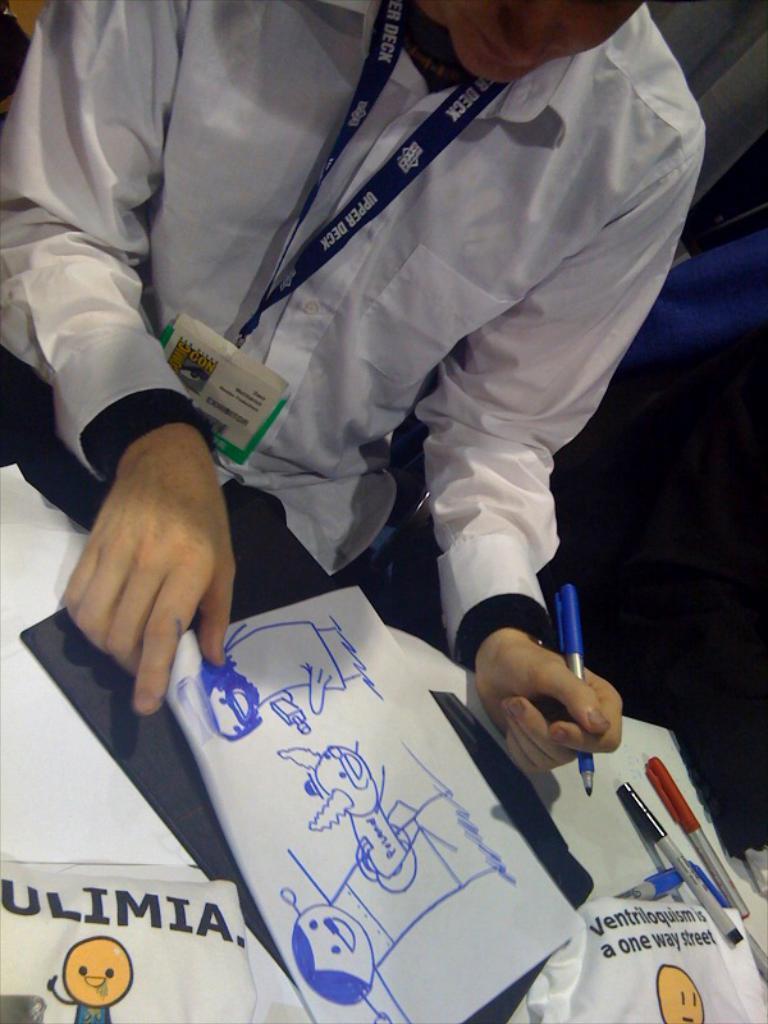In one or two sentences, can you explain what this image depicts? In this image we can see a man holding a pen and there is a table in front of him and we can see a paper with an art, pens and some other objects on the table. 